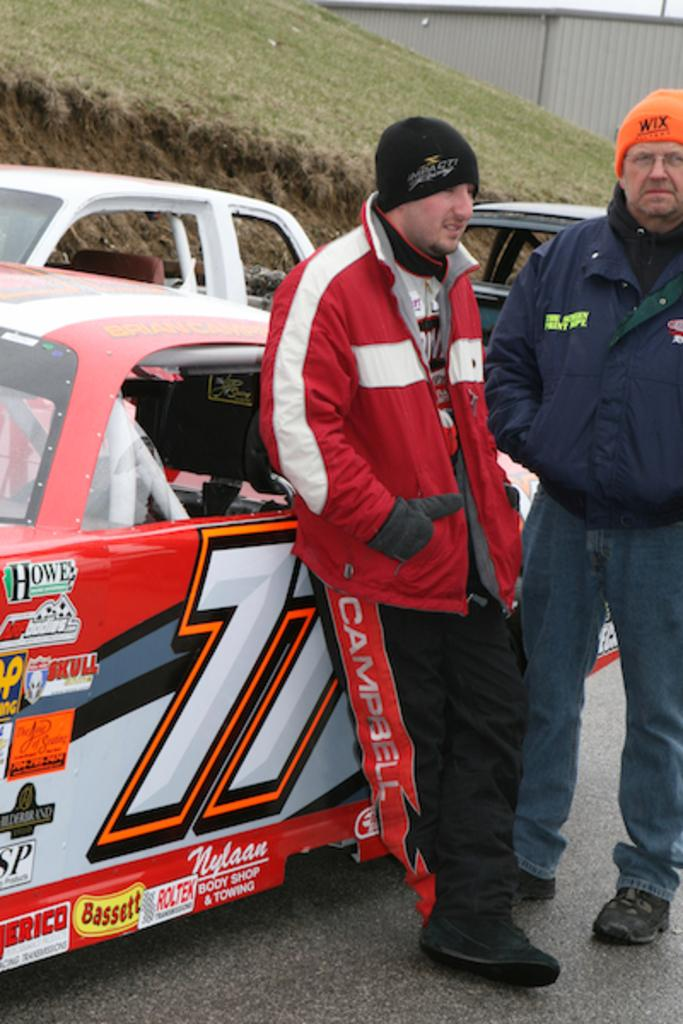How many people are in the image? There are two people in the image. What are the people wearing on their heads? Both people are wearing wool ski hats. Where are the people standing in the image? The people are standing on the road. What can be seen in the background of the image? There is a wall in the image. How many cars are on the road in the image? There are three cars on the road. What type of vegetation is visible on the mountain in the image? Green grass is visible on a mountain in the image. How many cents are visible on the ground in the image? There are no cents visible on the ground in the image. What type of bucket is being used by the people in the image? There is no bucket present in the image. 